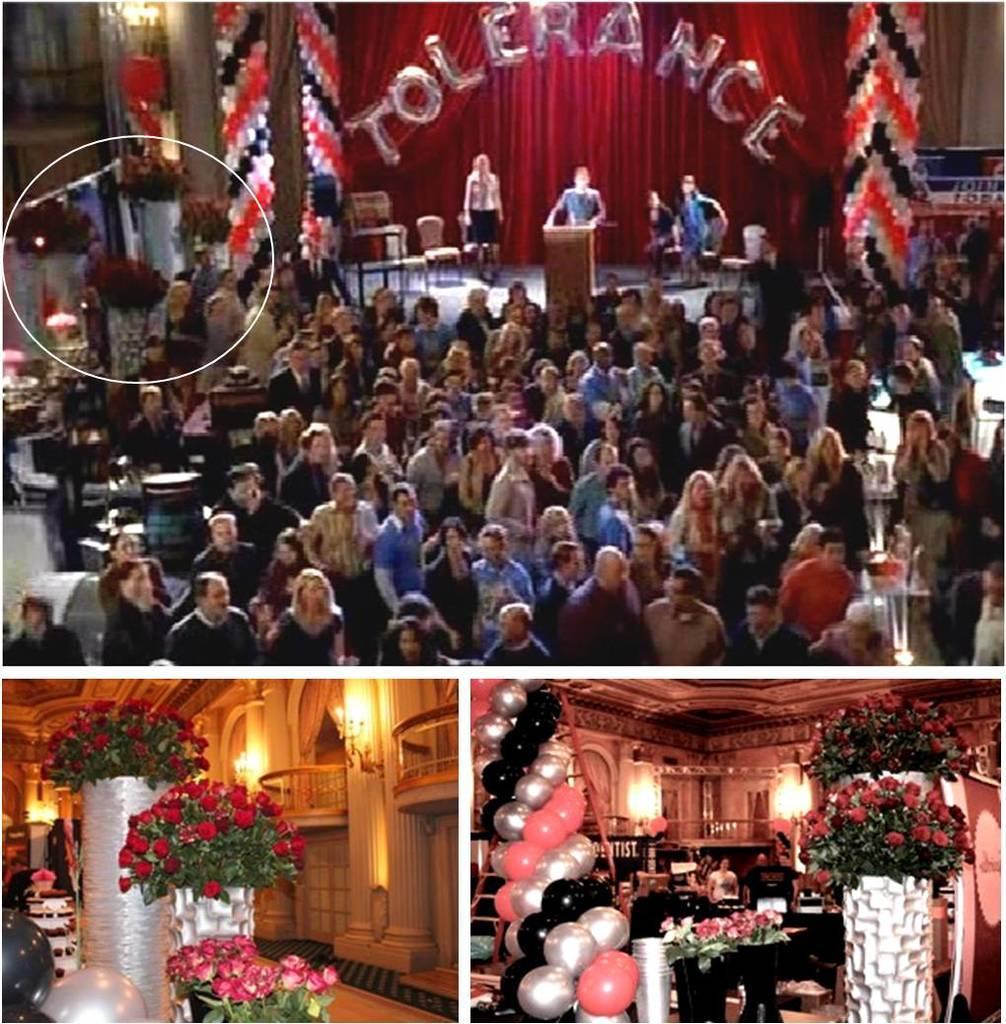Please provide a concise description of this image. In this image we can see a group of people standing on the floor. Here we can see four persons on the stage. Here we can see a person standing in front of a wooden podium. Here we can see the chairs on the stage. In the background, we can see the red cloth. Here we can see the flowers on the bottom left side. Here we can see the lightning arrangement. Here we can see the balloons. Here we can see the flowers on the bottom right side as well. 